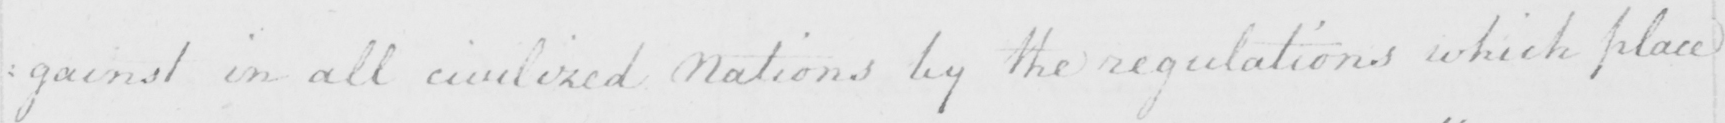What text is written in this handwritten line? : gainst in all civilized Nations by the regulations which place 